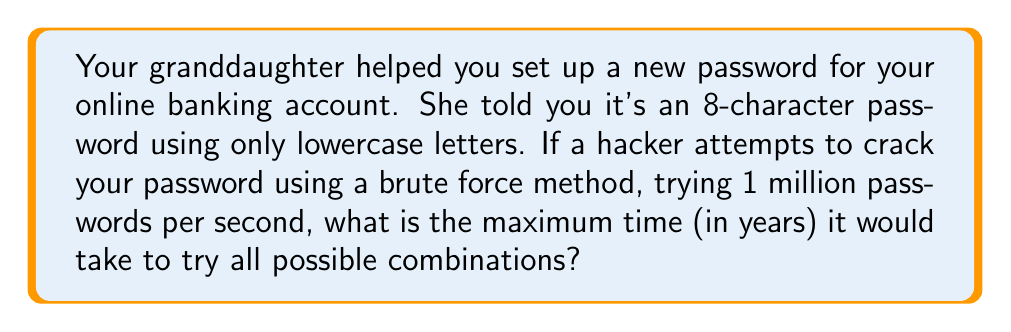What is the answer to this math problem? Let's approach this step-by-step:

1) First, we need to calculate the total number of possible combinations:
   - There are 26 lowercase letters in the English alphabet.
   - The password is 8 characters long.
   - So, the total number of combinations is $26^8$.

2) Calculate $26^8$:
   $26^8 = 208,827,064,576$

3) Now, we need to calculate how long it would take to try all these combinations:
   - The hacker can try 1 million (1,000,000) passwords per second.
   - Time = Total combinations / Combinations per second
   $Time = \frac{208,827,064,576}{1,000,000} = 208,827.064576$ seconds

4) Convert seconds to years:
   - There are 60 seconds in a minute, 60 minutes in an hour, 24 hours in a day, and approximately 365.25 days in a year (accounting for leap years).
   - So, seconds in a year = $60 * 60 * 24 * 365.25 = 31,557,600$

5) Calculate years:
   $Years = \frac{208,827.064576}{31,557,600} \approx 0.00661584$ years

Therefore, it would take approximately 0.00661584 years or about 2.42 days to try all possible combinations in the worst-case scenario.
Answer: 0.00661584 years 